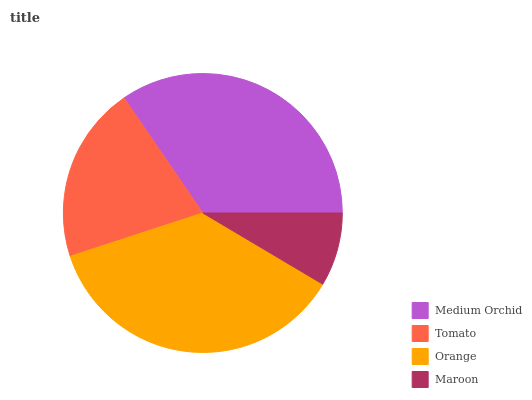Is Maroon the minimum?
Answer yes or no. Yes. Is Orange the maximum?
Answer yes or no. Yes. Is Tomato the minimum?
Answer yes or no. No. Is Tomato the maximum?
Answer yes or no. No. Is Medium Orchid greater than Tomato?
Answer yes or no. Yes. Is Tomato less than Medium Orchid?
Answer yes or no. Yes. Is Tomato greater than Medium Orchid?
Answer yes or no. No. Is Medium Orchid less than Tomato?
Answer yes or no. No. Is Medium Orchid the high median?
Answer yes or no. Yes. Is Tomato the low median?
Answer yes or no. Yes. Is Orange the high median?
Answer yes or no. No. Is Medium Orchid the low median?
Answer yes or no. No. 